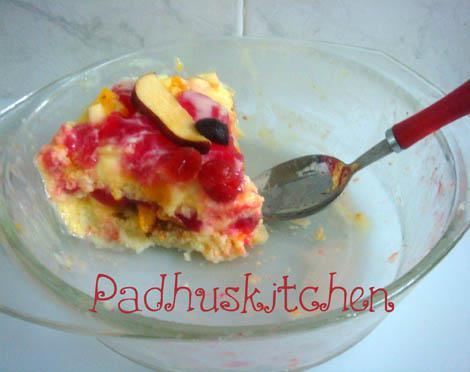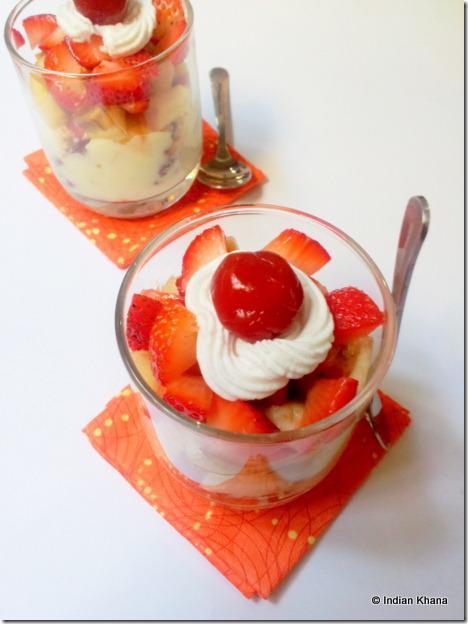The first image is the image on the left, the second image is the image on the right. Given the left and right images, does the statement "In at least one image, an untouched dessert is served in a large bowl, rather than individual serving dishes." hold true? Answer yes or no. No. 